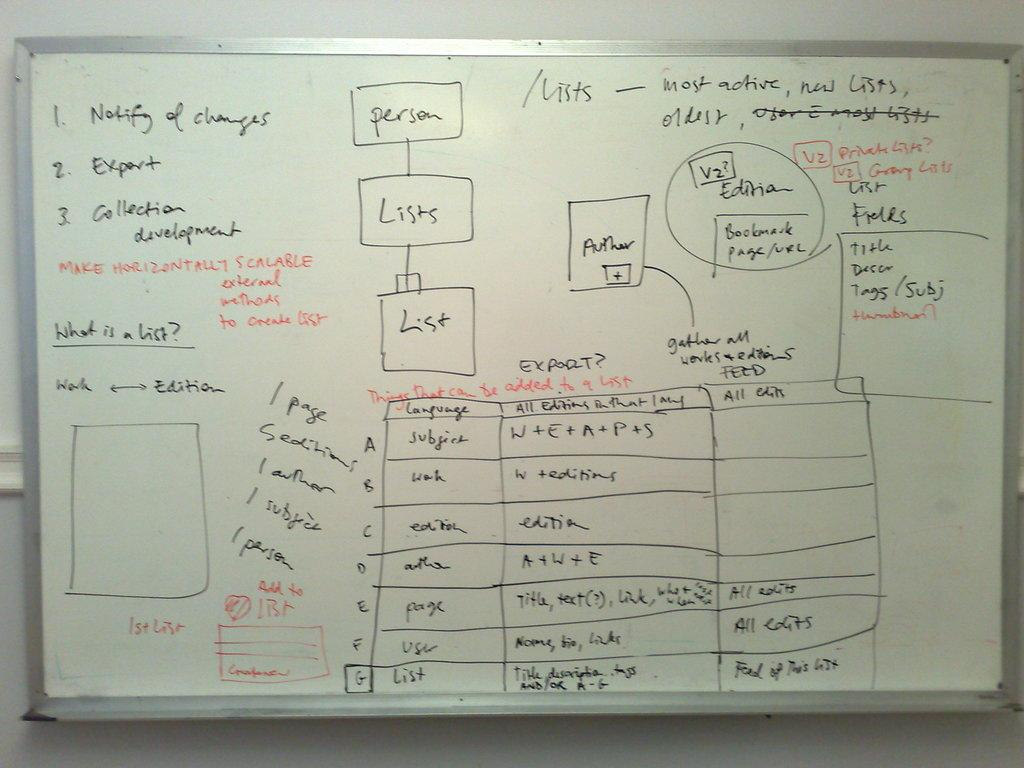Provide a one-sentence caption for the provided image. The first bullet point on the left says Notify of Changes. 